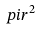<formula> <loc_0><loc_0><loc_500><loc_500>\ p i r ^ { 2 }</formula> 